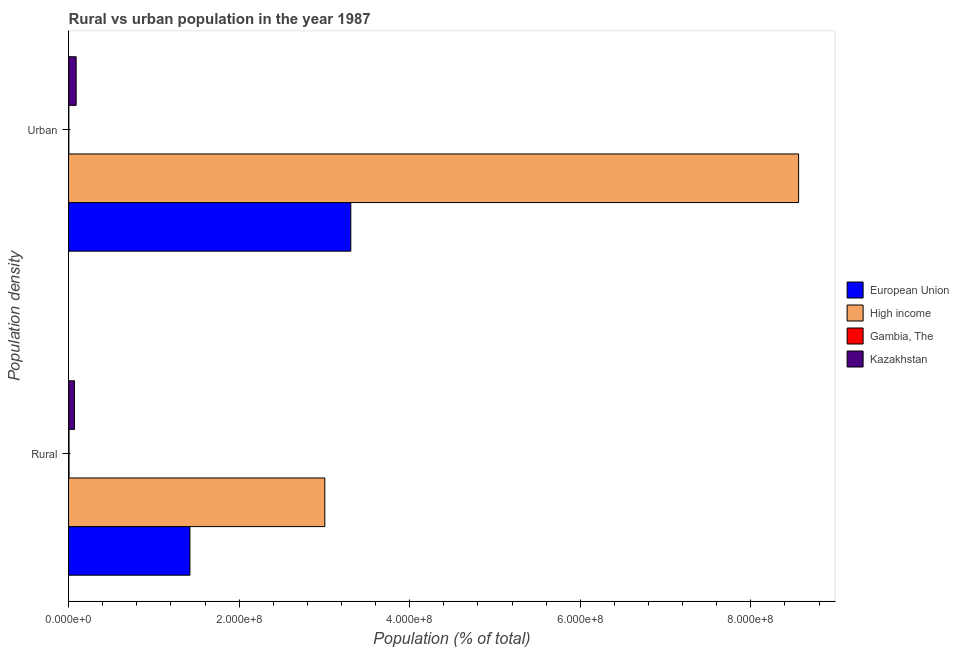How many groups of bars are there?
Provide a short and direct response. 2. Are the number of bars on each tick of the Y-axis equal?
Offer a very short reply. Yes. How many bars are there on the 1st tick from the top?
Offer a very short reply. 4. How many bars are there on the 2nd tick from the bottom?
Your answer should be very brief. 4. What is the label of the 2nd group of bars from the top?
Your response must be concise. Rural. What is the rural population density in Kazakhstan?
Ensure brevity in your answer.  6.92e+06. Across all countries, what is the maximum rural population density?
Your response must be concise. 3.00e+08. Across all countries, what is the minimum urban population density?
Keep it short and to the point. 2.82e+05. In which country was the rural population density minimum?
Give a very brief answer. Gambia, The. What is the total urban population density in the graph?
Make the answer very short. 1.20e+09. What is the difference between the rural population density in European Union and that in Gambia, The?
Your answer should be compact. 1.42e+08. What is the difference between the urban population density in High income and the rural population density in Gambia, The?
Offer a terse response. 8.56e+08. What is the average urban population density per country?
Make the answer very short. 2.99e+08. What is the difference between the rural population density and urban population density in Kazakhstan?
Provide a short and direct response. -1.97e+06. What is the ratio of the rural population density in High income to that in Kazakhstan?
Offer a terse response. 43.44. In how many countries, is the urban population density greater than the average urban population density taken over all countries?
Provide a succinct answer. 2. What does the 2nd bar from the top in Urban represents?
Provide a short and direct response. Gambia, The. What does the 4th bar from the bottom in Rural represents?
Your answer should be very brief. Kazakhstan. How many bars are there?
Your answer should be compact. 8. How many countries are there in the graph?
Offer a very short reply. 4. What is the difference between two consecutive major ticks on the X-axis?
Your answer should be compact. 2.00e+08. Are the values on the major ticks of X-axis written in scientific E-notation?
Provide a succinct answer. Yes. Does the graph contain grids?
Provide a short and direct response. No. What is the title of the graph?
Provide a short and direct response. Rural vs urban population in the year 1987. Does "South Asia" appear as one of the legend labels in the graph?
Ensure brevity in your answer.  No. What is the label or title of the X-axis?
Give a very brief answer. Population (% of total). What is the label or title of the Y-axis?
Keep it short and to the point. Population density. What is the Population (% of total) of European Union in Rural?
Your response must be concise. 1.42e+08. What is the Population (% of total) in High income in Rural?
Your answer should be compact. 3.00e+08. What is the Population (% of total) of Gambia, The in Rural?
Your answer should be very brief. 5.22e+05. What is the Population (% of total) of Kazakhstan in Rural?
Offer a terse response. 6.92e+06. What is the Population (% of total) of European Union in Urban?
Keep it short and to the point. 3.31e+08. What is the Population (% of total) in High income in Urban?
Keep it short and to the point. 8.56e+08. What is the Population (% of total) in Gambia, The in Urban?
Provide a short and direct response. 2.82e+05. What is the Population (% of total) of Kazakhstan in Urban?
Your response must be concise. 8.89e+06. Across all Population density, what is the maximum Population (% of total) of European Union?
Provide a succinct answer. 3.31e+08. Across all Population density, what is the maximum Population (% of total) in High income?
Provide a succinct answer. 8.56e+08. Across all Population density, what is the maximum Population (% of total) in Gambia, The?
Ensure brevity in your answer.  5.22e+05. Across all Population density, what is the maximum Population (% of total) of Kazakhstan?
Offer a very short reply. 8.89e+06. Across all Population density, what is the minimum Population (% of total) in European Union?
Ensure brevity in your answer.  1.42e+08. Across all Population density, what is the minimum Population (% of total) in High income?
Your answer should be compact. 3.00e+08. Across all Population density, what is the minimum Population (% of total) of Gambia, The?
Give a very brief answer. 2.82e+05. Across all Population density, what is the minimum Population (% of total) in Kazakhstan?
Your answer should be compact. 6.92e+06. What is the total Population (% of total) in European Union in the graph?
Offer a terse response. 4.73e+08. What is the total Population (% of total) in High income in the graph?
Give a very brief answer. 1.16e+09. What is the total Population (% of total) in Gambia, The in the graph?
Keep it short and to the point. 8.04e+05. What is the total Population (% of total) in Kazakhstan in the graph?
Offer a terse response. 1.58e+07. What is the difference between the Population (% of total) of European Union in Rural and that in Urban?
Offer a very short reply. -1.89e+08. What is the difference between the Population (% of total) in High income in Rural and that in Urban?
Give a very brief answer. -5.56e+08. What is the difference between the Population (% of total) of Gambia, The in Rural and that in Urban?
Ensure brevity in your answer.  2.40e+05. What is the difference between the Population (% of total) of Kazakhstan in Rural and that in Urban?
Provide a short and direct response. -1.97e+06. What is the difference between the Population (% of total) in European Union in Rural and the Population (% of total) in High income in Urban?
Your response must be concise. -7.14e+08. What is the difference between the Population (% of total) of European Union in Rural and the Population (% of total) of Gambia, The in Urban?
Ensure brevity in your answer.  1.42e+08. What is the difference between the Population (% of total) in European Union in Rural and the Population (% of total) in Kazakhstan in Urban?
Offer a very short reply. 1.33e+08. What is the difference between the Population (% of total) in High income in Rural and the Population (% of total) in Gambia, The in Urban?
Offer a very short reply. 3.00e+08. What is the difference between the Population (% of total) in High income in Rural and the Population (% of total) in Kazakhstan in Urban?
Make the answer very short. 2.92e+08. What is the difference between the Population (% of total) of Gambia, The in Rural and the Population (% of total) of Kazakhstan in Urban?
Ensure brevity in your answer.  -8.36e+06. What is the average Population (% of total) in European Union per Population density?
Your answer should be very brief. 2.37e+08. What is the average Population (% of total) in High income per Population density?
Keep it short and to the point. 5.78e+08. What is the average Population (% of total) in Gambia, The per Population density?
Offer a very short reply. 4.02e+05. What is the average Population (% of total) of Kazakhstan per Population density?
Keep it short and to the point. 7.90e+06. What is the difference between the Population (% of total) in European Union and Population (% of total) in High income in Rural?
Give a very brief answer. -1.58e+08. What is the difference between the Population (% of total) in European Union and Population (% of total) in Gambia, The in Rural?
Your answer should be compact. 1.42e+08. What is the difference between the Population (% of total) of European Union and Population (% of total) of Kazakhstan in Rural?
Your answer should be compact. 1.35e+08. What is the difference between the Population (% of total) in High income and Population (% of total) in Gambia, The in Rural?
Provide a succinct answer. 3.00e+08. What is the difference between the Population (% of total) of High income and Population (% of total) of Kazakhstan in Rural?
Your answer should be compact. 2.94e+08. What is the difference between the Population (% of total) in Gambia, The and Population (% of total) in Kazakhstan in Rural?
Make the answer very short. -6.39e+06. What is the difference between the Population (% of total) of European Union and Population (% of total) of High income in Urban?
Provide a short and direct response. -5.25e+08. What is the difference between the Population (% of total) of European Union and Population (% of total) of Gambia, The in Urban?
Make the answer very short. 3.31e+08. What is the difference between the Population (% of total) of European Union and Population (% of total) of Kazakhstan in Urban?
Provide a succinct answer. 3.22e+08. What is the difference between the Population (% of total) in High income and Population (% of total) in Gambia, The in Urban?
Provide a succinct answer. 8.56e+08. What is the difference between the Population (% of total) in High income and Population (% of total) in Kazakhstan in Urban?
Your answer should be very brief. 8.47e+08. What is the difference between the Population (% of total) of Gambia, The and Population (% of total) of Kazakhstan in Urban?
Ensure brevity in your answer.  -8.60e+06. What is the ratio of the Population (% of total) in European Union in Rural to that in Urban?
Keep it short and to the point. 0.43. What is the ratio of the Population (% of total) of High income in Rural to that in Urban?
Keep it short and to the point. 0.35. What is the ratio of the Population (% of total) in Gambia, The in Rural to that in Urban?
Your answer should be very brief. 1.85. What is the ratio of the Population (% of total) in Kazakhstan in Rural to that in Urban?
Your answer should be compact. 0.78. What is the difference between the highest and the second highest Population (% of total) in European Union?
Ensure brevity in your answer.  1.89e+08. What is the difference between the highest and the second highest Population (% of total) in High income?
Offer a very short reply. 5.56e+08. What is the difference between the highest and the second highest Population (% of total) in Gambia, The?
Give a very brief answer. 2.40e+05. What is the difference between the highest and the second highest Population (% of total) in Kazakhstan?
Offer a terse response. 1.97e+06. What is the difference between the highest and the lowest Population (% of total) in European Union?
Keep it short and to the point. 1.89e+08. What is the difference between the highest and the lowest Population (% of total) of High income?
Your answer should be compact. 5.56e+08. What is the difference between the highest and the lowest Population (% of total) in Gambia, The?
Offer a very short reply. 2.40e+05. What is the difference between the highest and the lowest Population (% of total) in Kazakhstan?
Provide a succinct answer. 1.97e+06. 